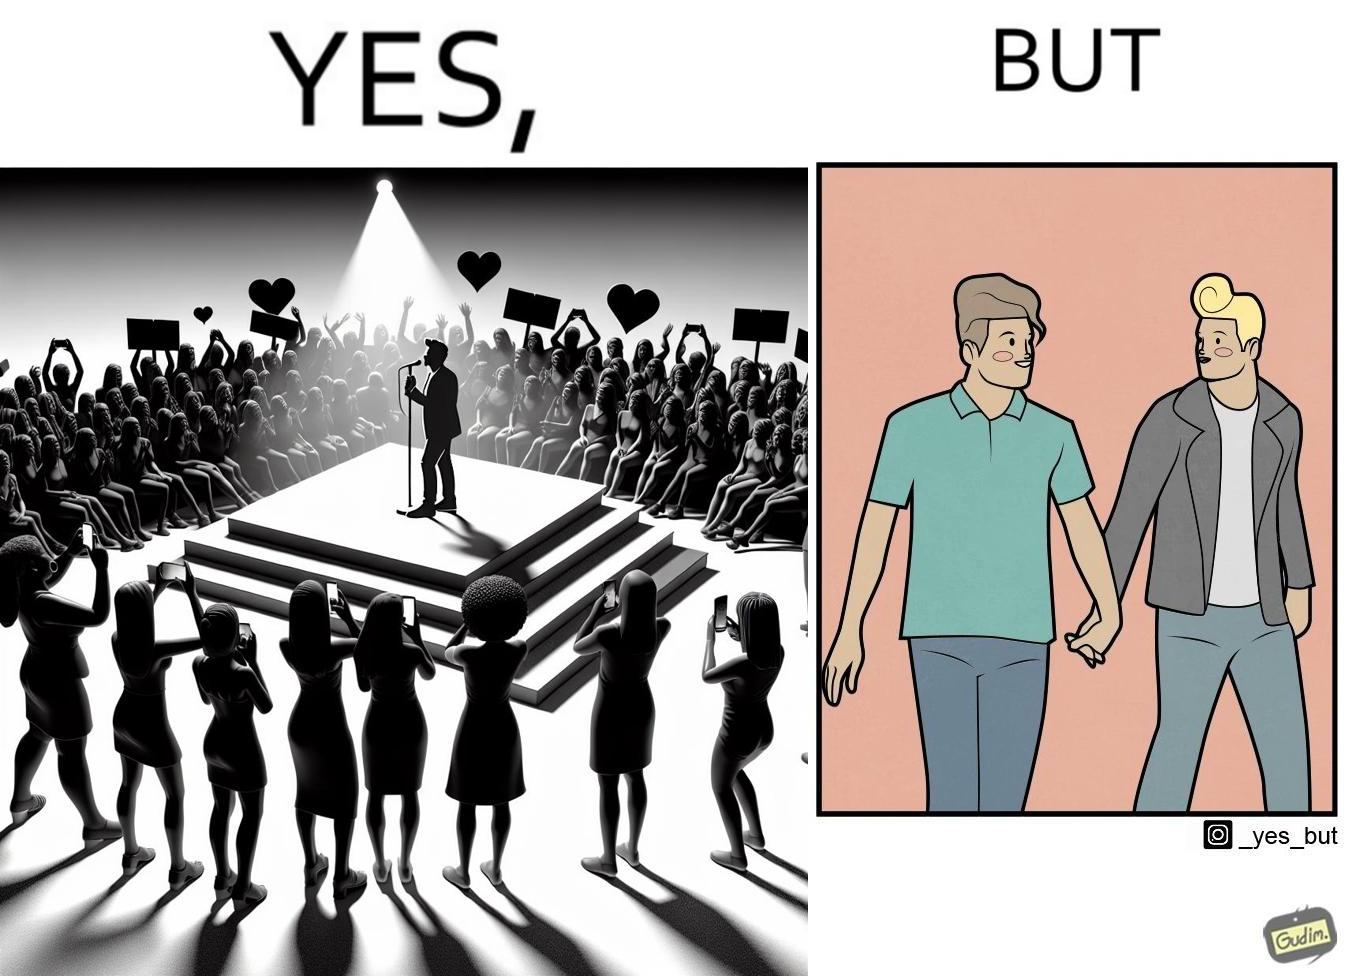What does this image depict? The image is funny because while the girls loves the man, he likes other men instead of women. 